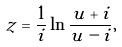Convert formula to latex. <formula><loc_0><loc_0><loc_500><loc_500>z = \frac { 1 } { i } \ln \frac { u + i } { u - i } ,</formula> 